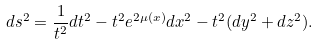Convert formula to latex. <formula><loc_0><loc_0><loc_500><loc_500>d s ^ { 2 } = \frac { 1 } { t ^ { 2 } } d t ^ { 2 } - t ^ { 2 } e ^ { 2 \mu ( x ) } d x ^ { 2 } - t ^ { 2 } ( d y ^ { 2 } + d z ^ { 2 } ) .</formula> 